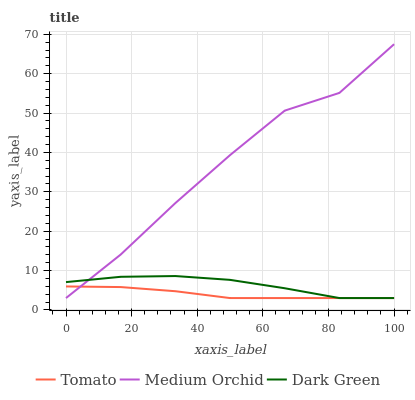Does Tomato have the minimum area under the curve?
Answer yes or no. Yes. Does Medium Orchid have the maximum area under the curve?
Answer yes or no. Yes. Does Dark Green have the minimum area under the curve?
Answer yes or no. No. Does Dark Green have the maximum area under the curve?
Answer yes or no. No. Is Tomato the smoothest?
Answer yes or no. Yes. Is Medium Orchid the roughest?
Answer yes or no. Yes. Is Dark Green the smoothest?
Answer yes or no. No. Is Dark Green the roughest?
Answer yes or no. No. Does Tomato have the lowest value?
Answer yes or no. Yes. Does Medium Orchid have the highest value?
Answer yes or no. Yes. Does Dark Green have the highest value?
Answer yes or no. No. Does Medium Orchid intersect Dark Green?
Answer yes or no. Yes. Is Medium Orchid less than Dark Green?
Answer yes or no. No. Is Medium Orchid greater than Dark Green?
Answer yes or no. No. 